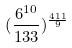Convert formula to latex. <formula><loc_0><loc_0><loc_500><loc_500>( \frac { 6 ^ { 1 0 } } { 1 3 3 } ) ^ { \frac { 4 1 1 } { 9 } }</formula> 